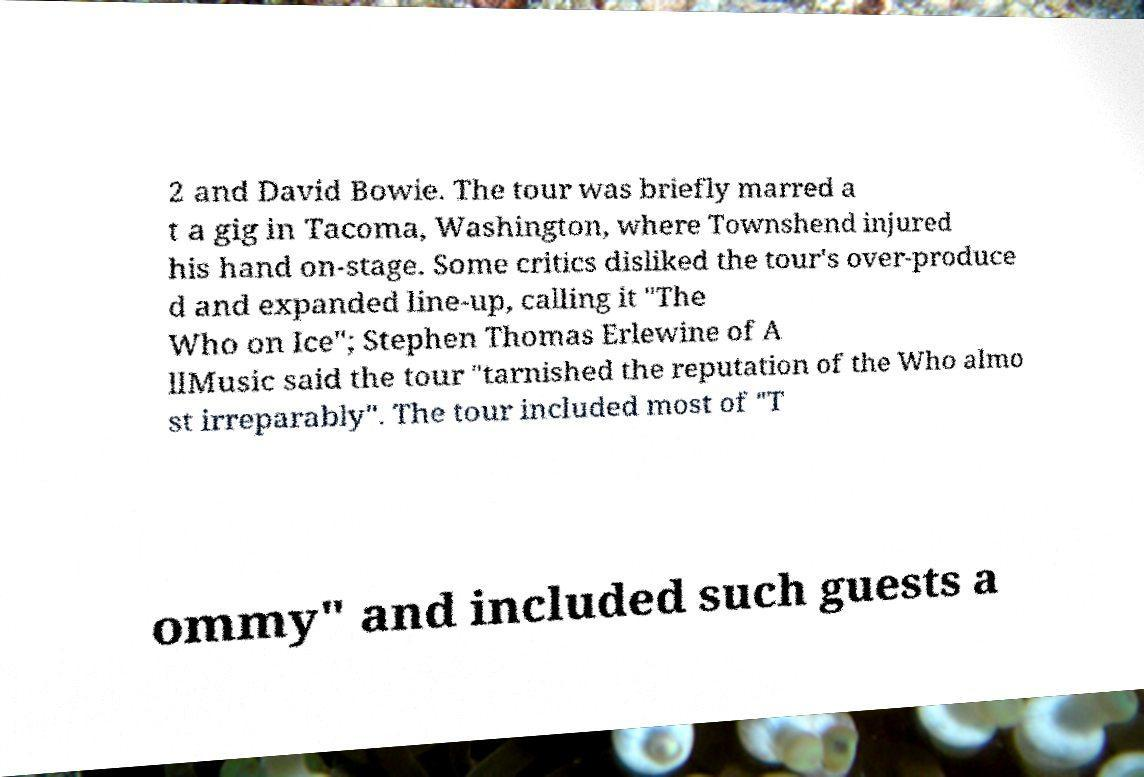Can you read and provide the text displayed in the image?This photo seems to have some interesting text. Can you extract and type it out for me? 2 and David Bowie. The tour was briefly marred a t a gig in Tacoma, Washington, where Townshend injured his hand on-stage. Some critics disliked the tour's over-produce d and expanded line-up, calling it "The Who on Ice"; Stephen Thomas Erlewine of A llMusic said the tour "tarnished the reputation of the Who almo st irreparably". The tour included most of "T ommy" and included such guests a 